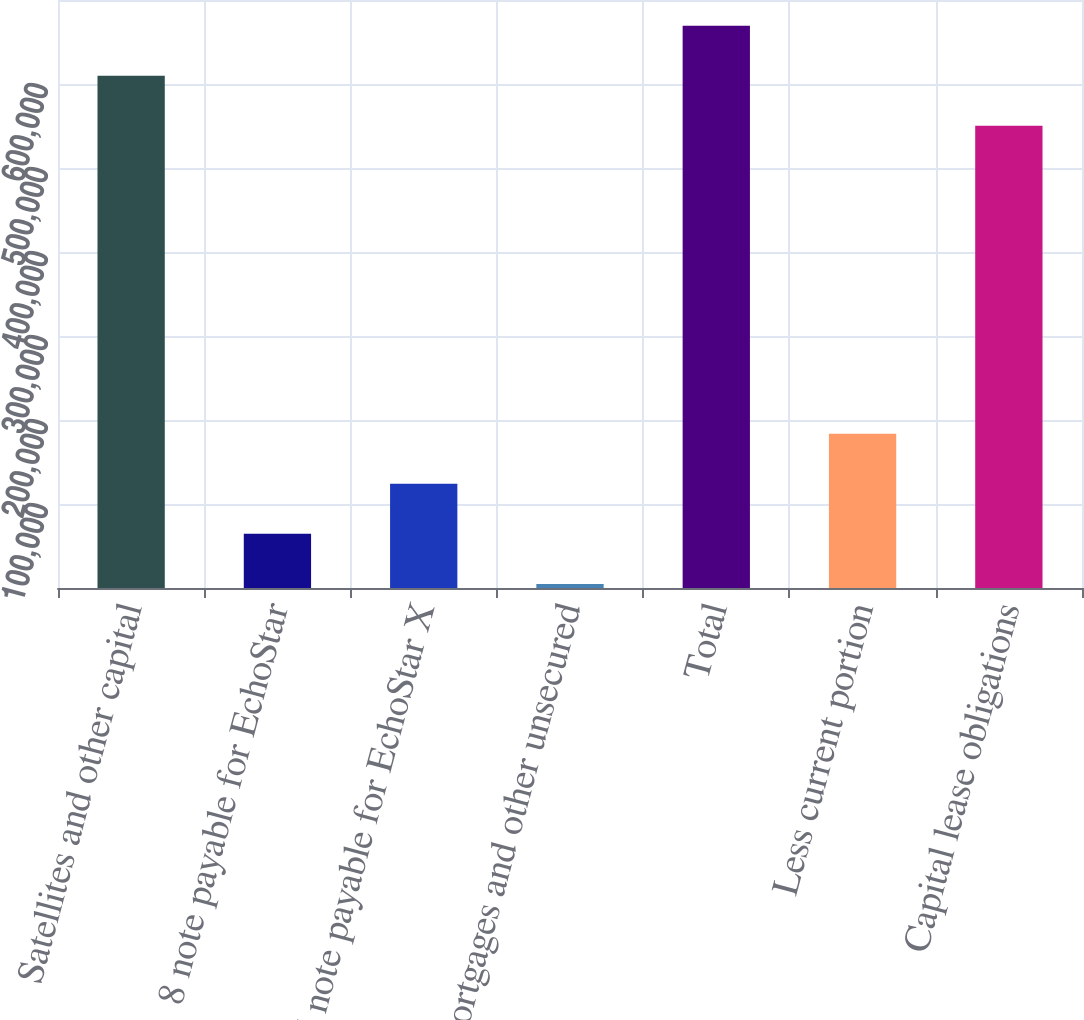Convert chart to OTSL. <chart><loc_0><loc_0><loc_500><loc_500><bar_chart><fcel>Satellites and other capital<fcel>8 note payable for EchoStar<fcel>6 note payable for EchoStar X<fcel>Mortgages and other unsecured<fcel>Total<fcel>Less current portion<fcel>Capital lease obligations<nl><fcel>609834<fcel>64448<fcel>124032<fcel>4864<fcel>669418<fcel>183616<fcel>550250<nl></chart> 